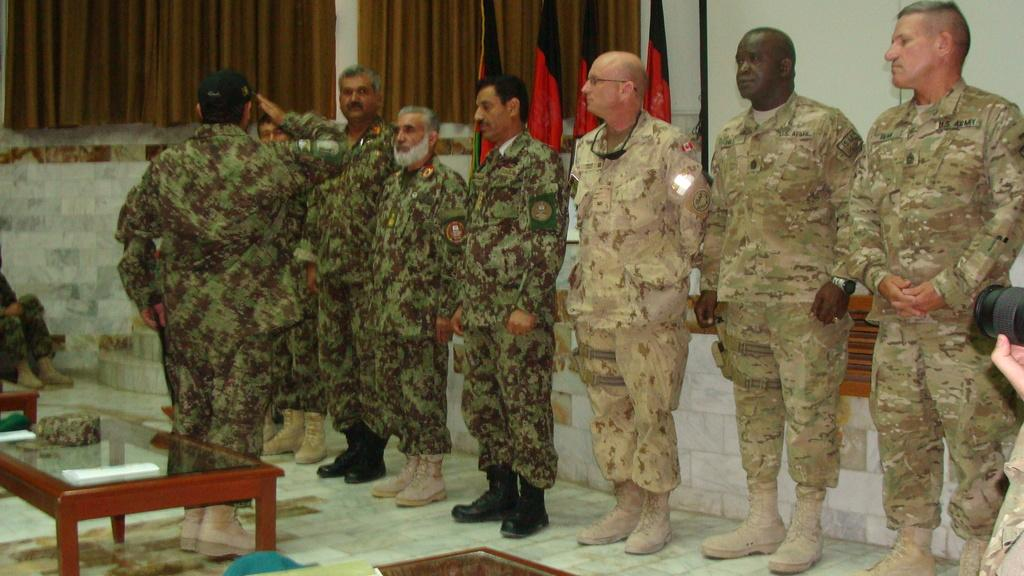What is happening in the image involving the group of people? There is a group of people standing in the image. What can be seen in the background behind the people? There are flags behind the people. What is located at the left side of the image? There is a curtain at the left side of the image. What type of furniture is present in the image? There are tables in the image. What type of recess is visible in the image? There is no recess present in the image. What are the people talking about in the image? The image does not provide any information about what the people might be talking about. 